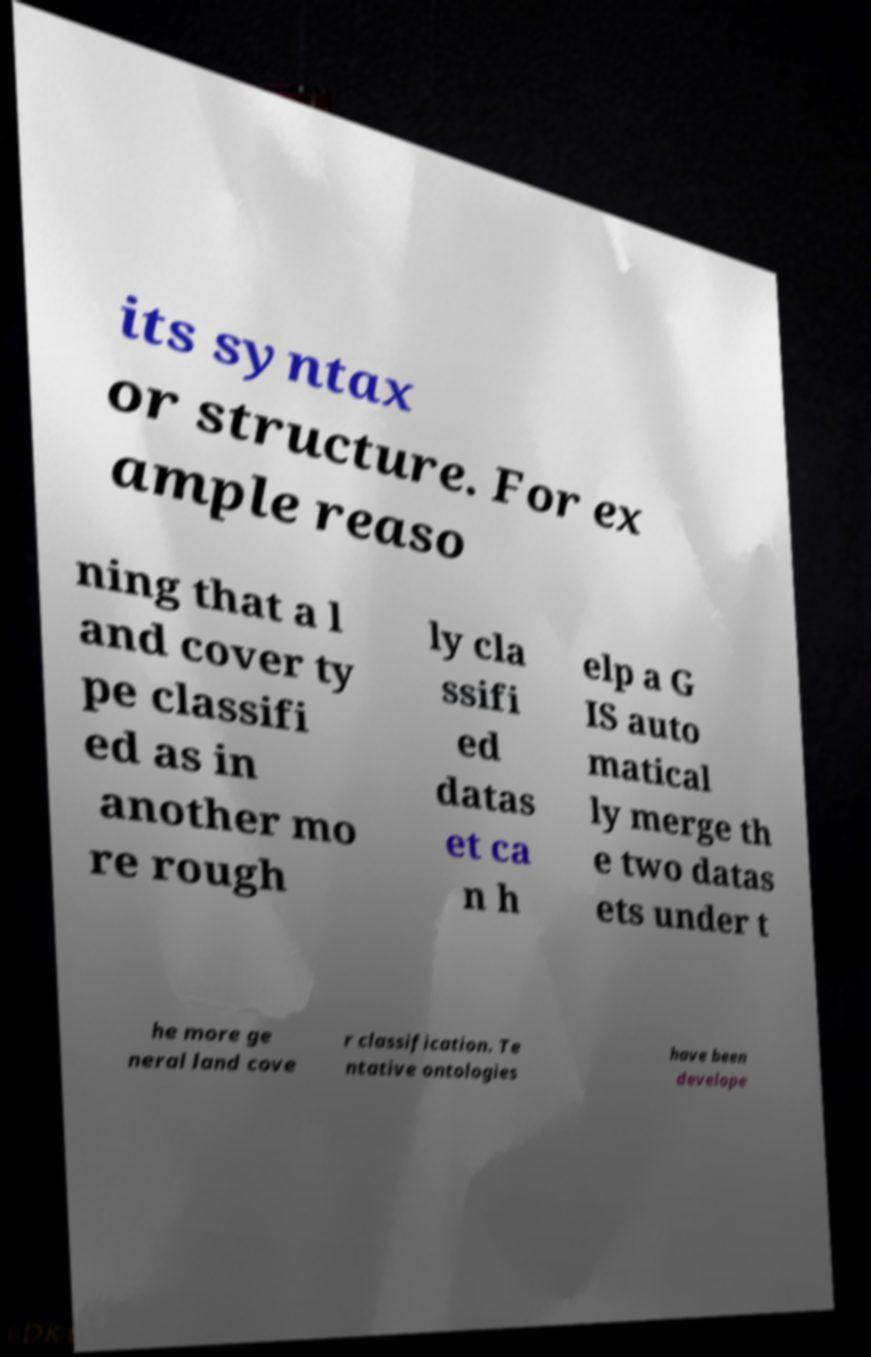What messages or text are displayed in this image? I need them in a readable, typed format. its syntax or structure. For ex ample reaso ning that a l and cover ty pe classifi ed as in another mo re rough ly cla ssifi ed datas et ca n h elp a G IS auto matical ly merge th e two datas ets under t he more ge neral land cove r classification. Te ntative ontologies have been develope 